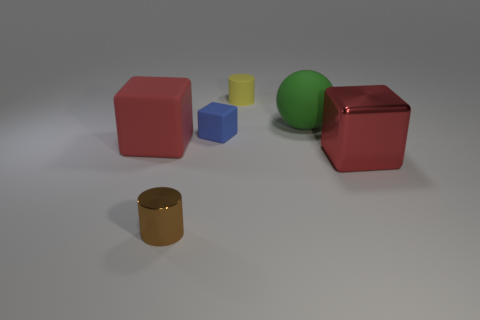There is a big cube left of the big red shiny block; is it the same color as the shiny block?
Your response must be concise. Yes. Does the large object right of the green object have the same color as the large cube that is left of the big red shiny thing?
Offer a terse response. Yes. Is the color of the big matte ball the same as the big matte block?
Make the answer very short. No. There is a red block that is on the left side of the blue object; what is its size?
Offer a very short reply. Large. What is the shape of the brown object?
Give a very brief answer. Cylinder. Does the shiny thing right of the green object have the same size as the block that is on the left side of the small blue rubber block?
Offer a very short reply. Yes. There is a shiny thing that is left of the matte cube behind the big block that is on the left side of the small blue matte object; what size is it?
Provide a succinct answer. Small. The metal thing on the left side of the cylinder that is on the right side of the metal object that is on the left side of the tiny cube is what shape?
Offer a very short reply. Cylinder. What shape is the big red matte thing in front of the tiny yellow thing?
Make the answer very short. Cube. Is the green sphere made of the same material as the thing that is right of the green rubber thing?
Keep it short and to the point. No. 